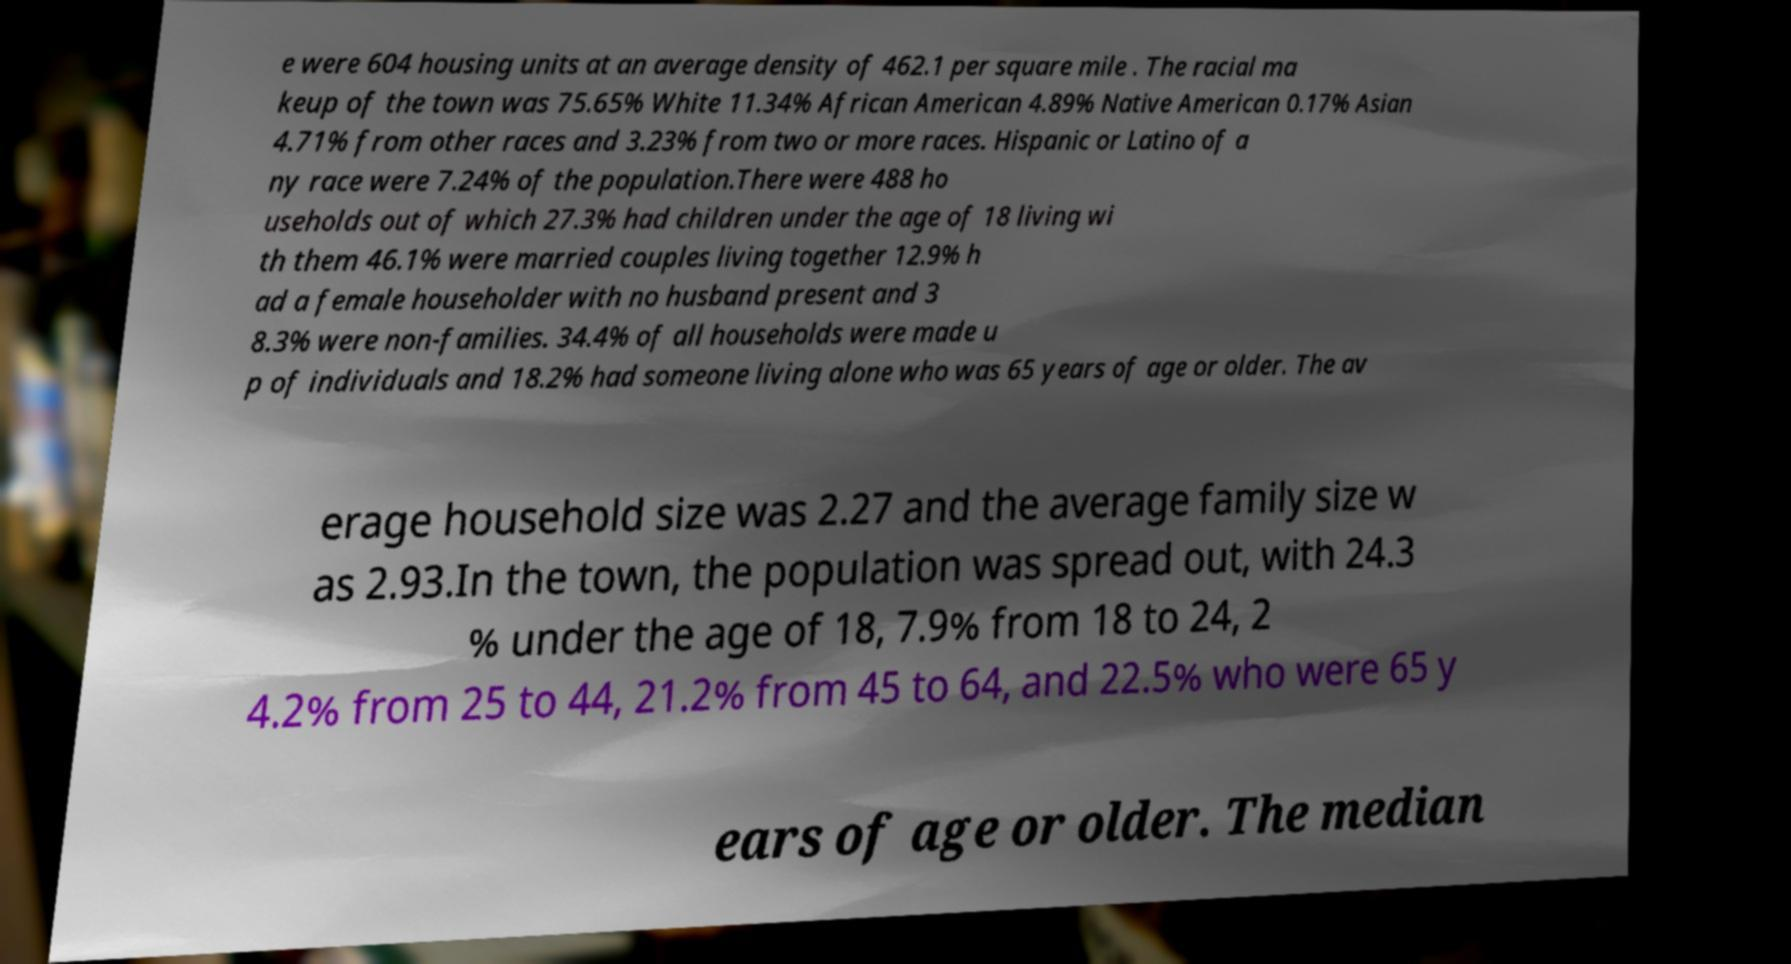Please read and relay the text visible in this image. What does it say? e were 604 housing units at an average density of 462.1 per square mile . The racial ma keup of the town was 75.65% White 11.34% African American 4.89% Native American 0.17% Asian 4.71% from other races and 3.23% from two or more races. Hispanic or Latino of a ny race were 7.24% of the population.There were 488 ho useholds out of which 27.3% had children under the age of 18 living wi th them 46.1% were married couples living together 12.9% h ad a female householder with no husband present and 3 8.3% were non-families. 34.4% of all households were made u p of individuals and 18.2% had someone living alone who was 65 years of age or older. The av erage household size was 2.27 and the average family size w as 2.93.In the town, the population was spread out, with 24.3 % under the age of 18, 7.9% from 18 to 24, 2 4.2% from 25 to 44, 21.2% from 45 to 64, and 22.5% who were 65 y ears of age or older. The median 